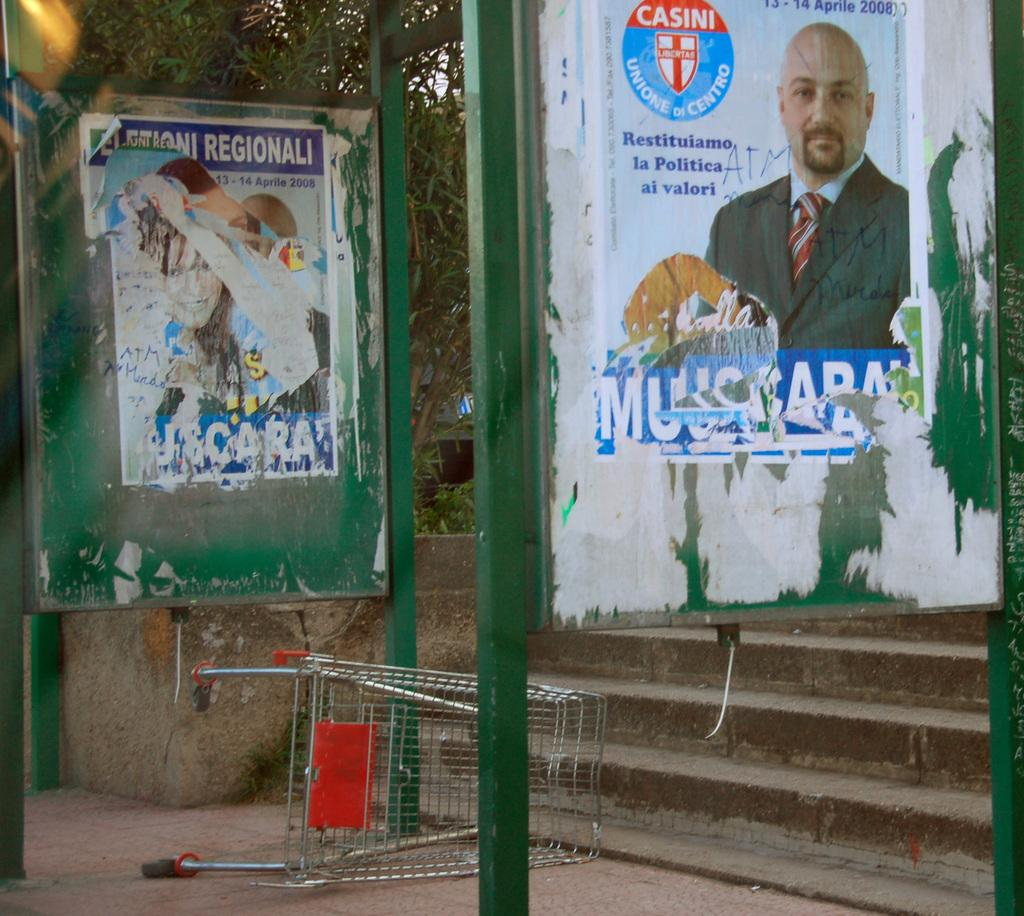<image>
Write a terse but informative summary of the picture. An old poster for a politician with the CASINI logo on it 